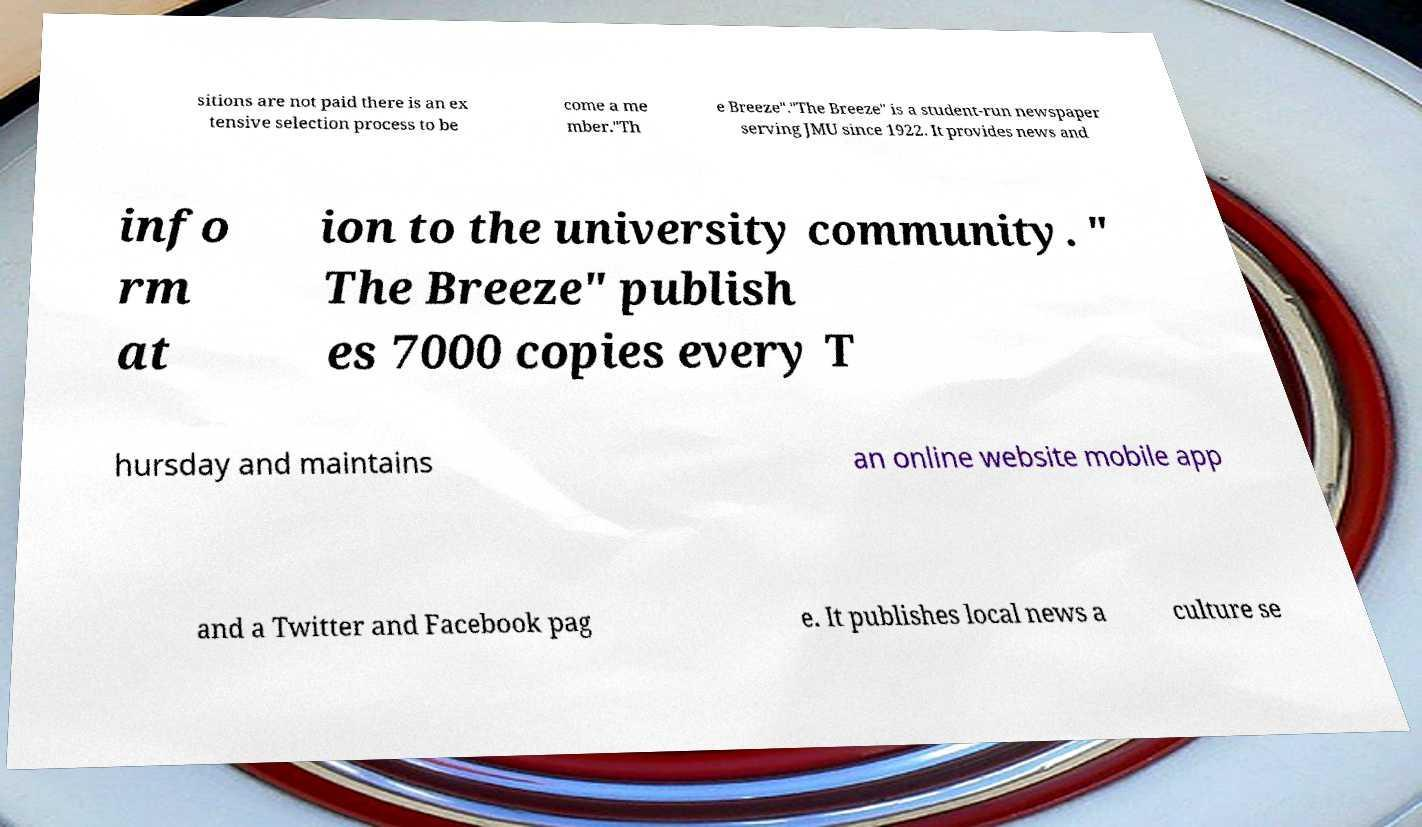I need the written content from this picture converted into text. Can you do that? sitions are not paid there is an ex tensive selection process to be come a me mber."Th e Breeze"."The Breeze" is a student-run newspaper serving JMU since 1922. It provides news and info rm at ion to the university community. " The Breeze" publish es 7000 copies every T hursday and maintains an online website mobile app and a Twitter and Facebook pag e. It publishes local news a culture se 